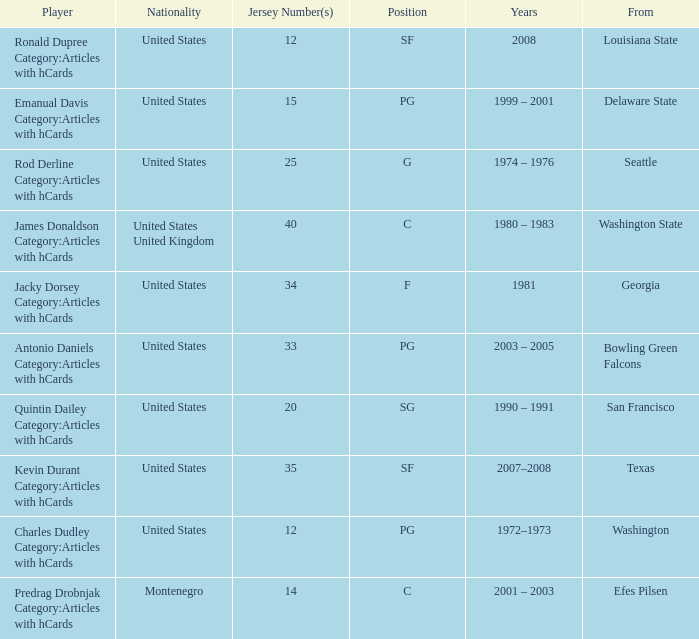What college was the player with the jersey number of 34 from? Georgia. Can you parse all the data within this table? {'header': ['Player', 'Nationality', 'Jersey Number(s)', 'Position', 'Years', 'From'], 'rows': [['Ronald Dupree Category:Articles with hCards', 'United States', '12', 'SF', '2008', 'Louisiana State'], ['Emanual Davis Category:Articles with hCards', 'United States', '15', 'PG', '1999 – 2001', 'Delaware State'], ['Rod Derline Category:Articles with hCards', 'United States', '25', 'G', '1974 – 1976', 'Seattle'], ['James Donaldson Category:Articles with hCards', 'United States United Kingdom', '40', 'C', '1980 – 1983', 'Washington State'], ['Jacky Dorsey Category:Articles with hCards', 'United States', '34', 'F', '1981', 'Georgia'], ['Antonio Daniels Category:Articles with hCards', 'United States', '33', 'PG', '2003 – 2005', 'Bowling Green Falcons'], ['Quintin Dailey Category:Articles with hCards', 'United States', '20', 'SG', '1990 – 1991', 'San Francisco'], ['Kevin Durant Category:Articles with hCards', 'United States', '35', 'SF', '2007–2008', 'Texas'], ['Charles Dudley Category:Articles with hCards', 'United States', '12', 'PG', '1972–1973', 'Washington'], ['Predrag Drobnjak Category:Articles with hCards', 'Montenegro', '14', 'C', '2001 – 2003', 'Efes Pilsen']]} 